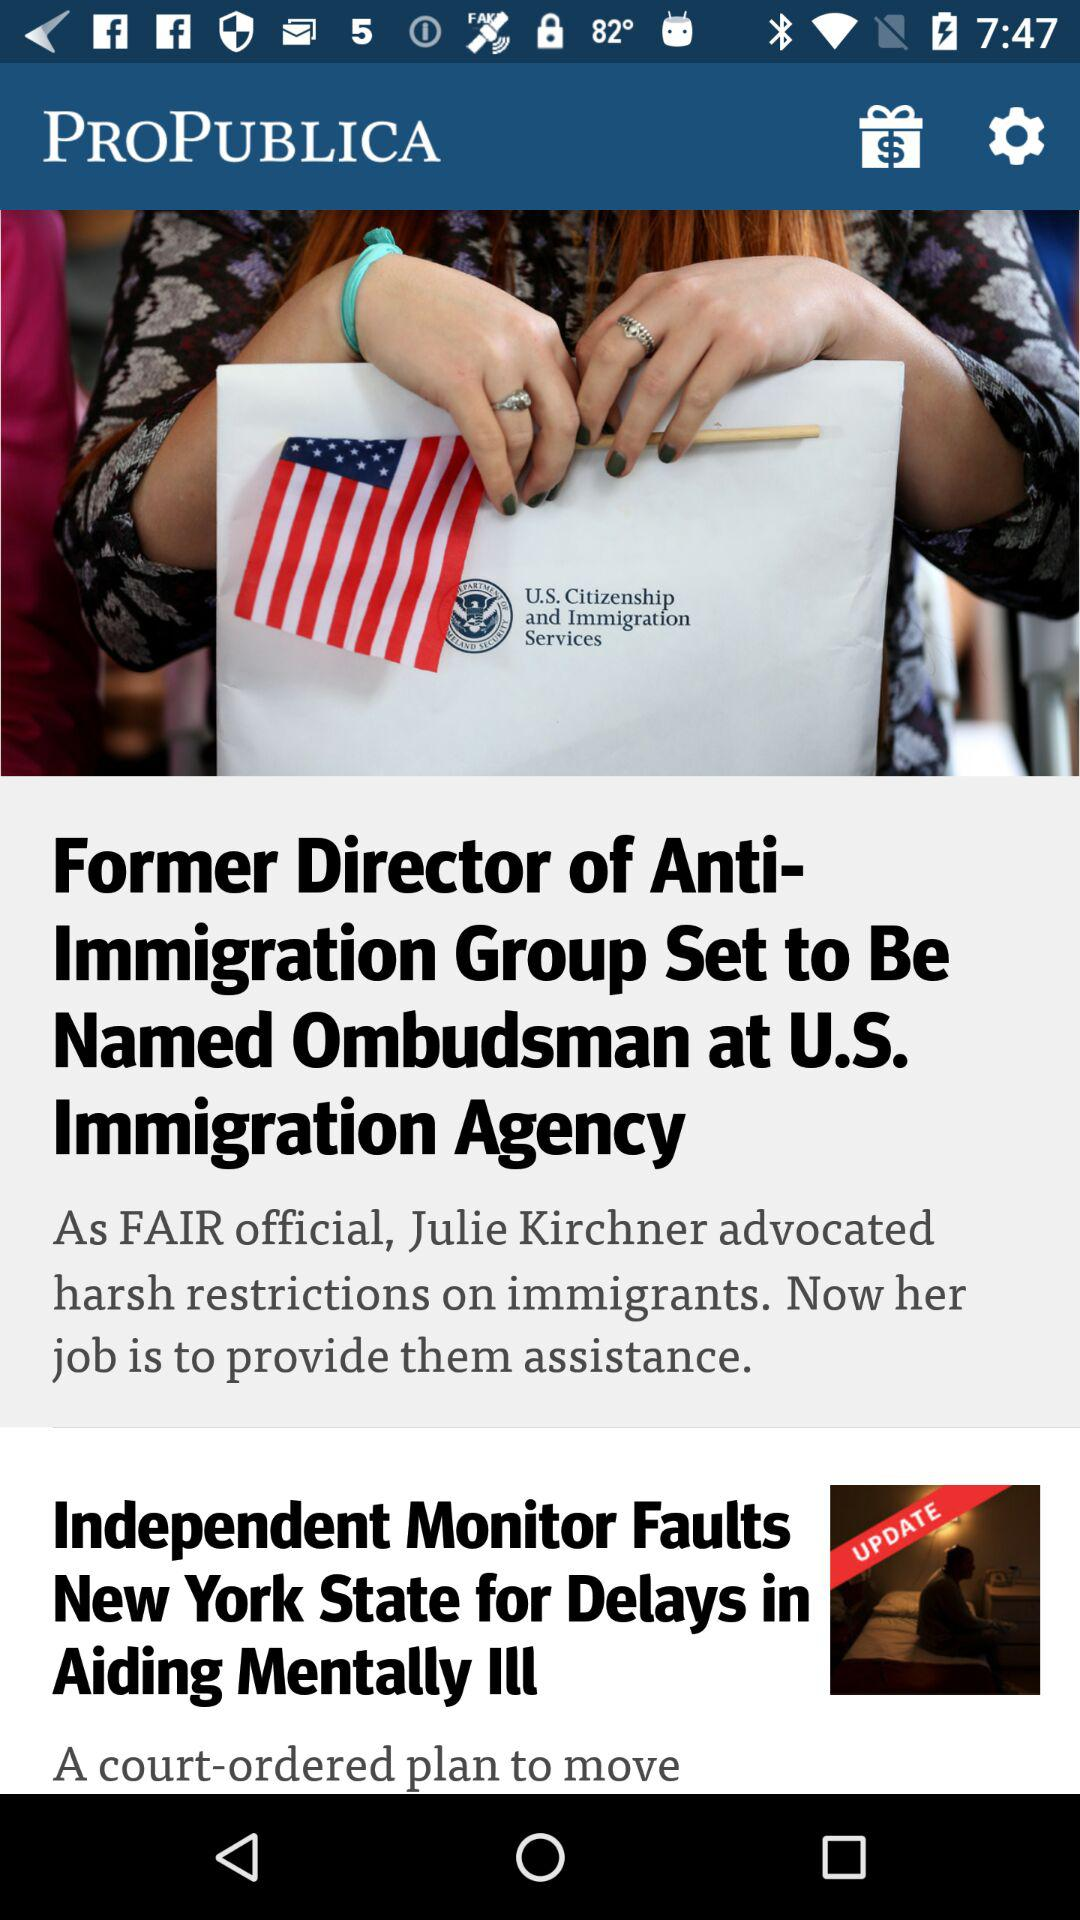What is the app name? The app name is "ProPublica". 